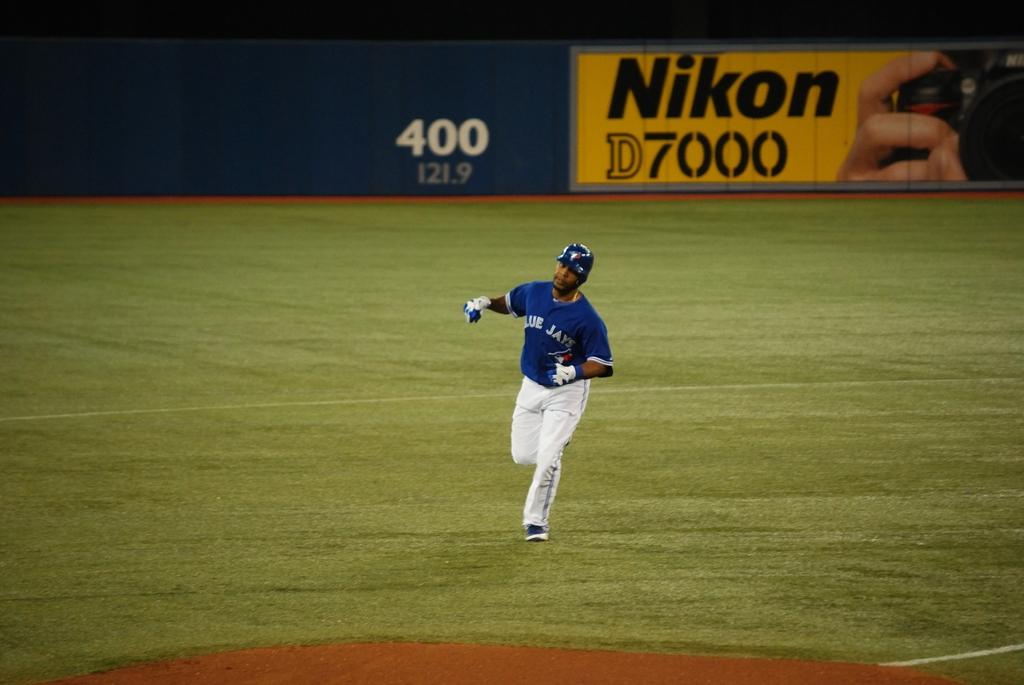What camera brand is the advertisement for?
Your answer should be very brief. Nikon. What model of camera is being advertised?
Provide a succinct answer. Nikon d7000. 